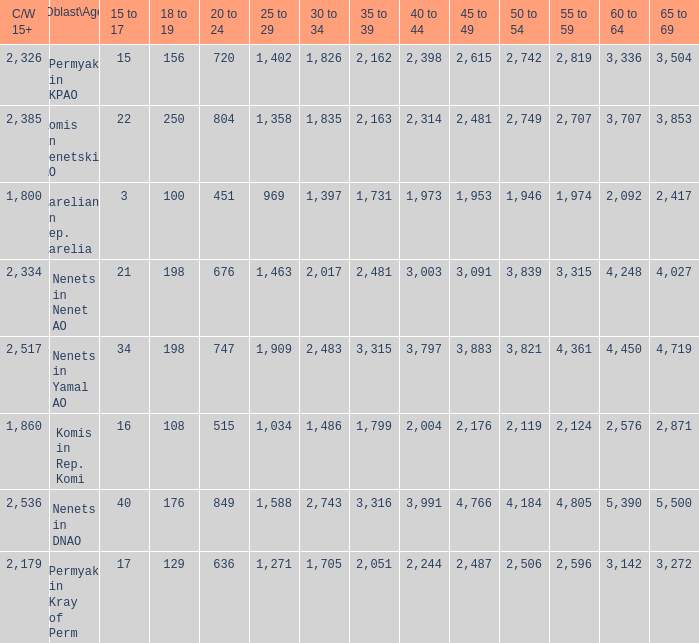What is the number of 40 to 44 when the 50 to 54 is less than 4,184, and the 15 to 17 is less than 3? 0.0. 